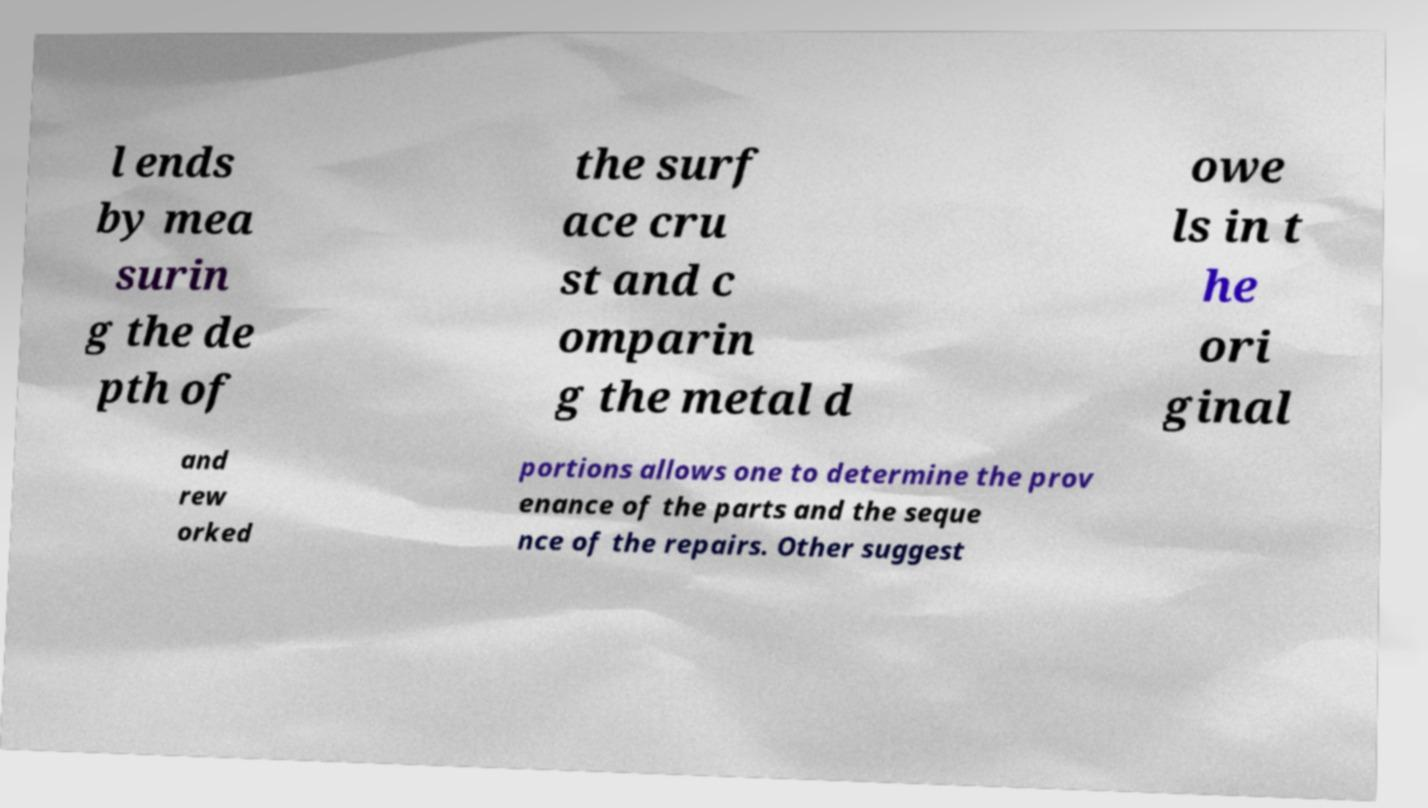Could you assist in decoding the text presented in this image and type it out clearly? l ends by mea surin g the de pth of the surf ace cru st and c omparin g the metal d owe ls in t he ori ginal and rew orked portions allows one to determine the prov enance of the parts and the seque nce of the repairs. Other suggest 